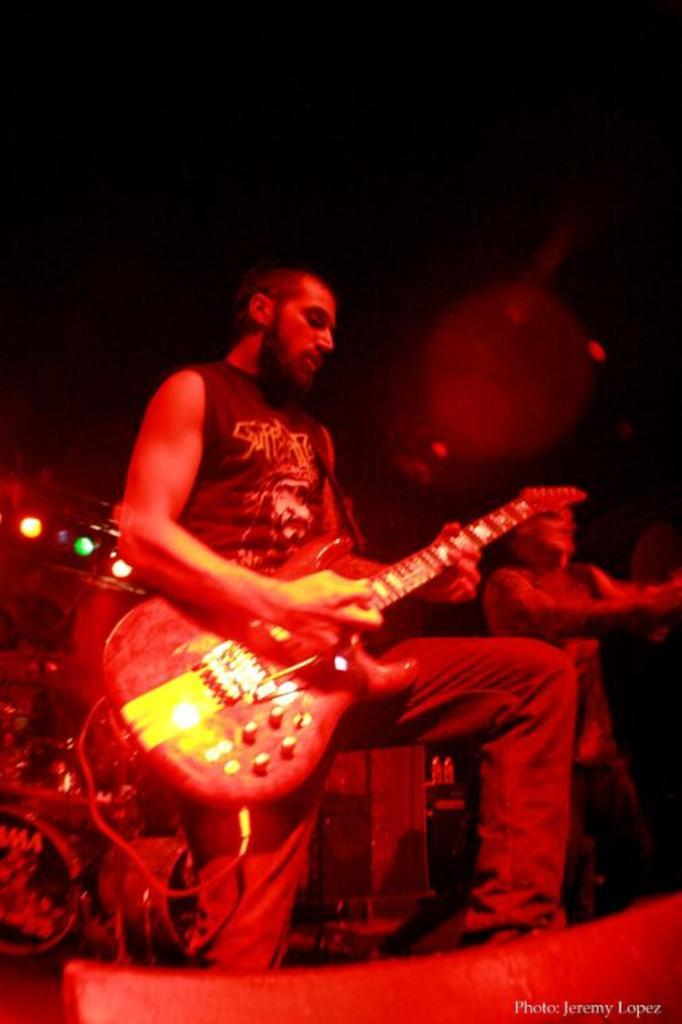What is the man in the image doing? The man is playing a guitar in the image. What is happening on the right side of the image? There is a person dancing on the right side of the image. What other musical instrument can be seen in the image? There is a musical instrument, possibly a drum, on the left side of the image. Can you describe the lighting in the image? There is a light in the image. How many people are saying good-bye in the image? There is no indication of anyone saying good-bye in the image. What type of crowd can be seen gathering around the church in the image? There is no crowd or church present in the image. 